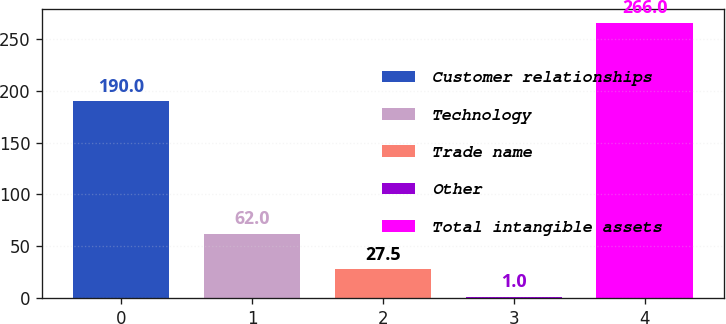Convert chart to OTSL. <chart><loc_0><loc_0><loc_500><loc_500><bar_chart><fcel>Customer relationships<fcel>Technology<fcel>Trade name<fcel>Other<fcel>Total intangible assets<nl><fcel>190<fcel>62<fcel>27.5<fcel>1<fcel>266<nl></chart> 